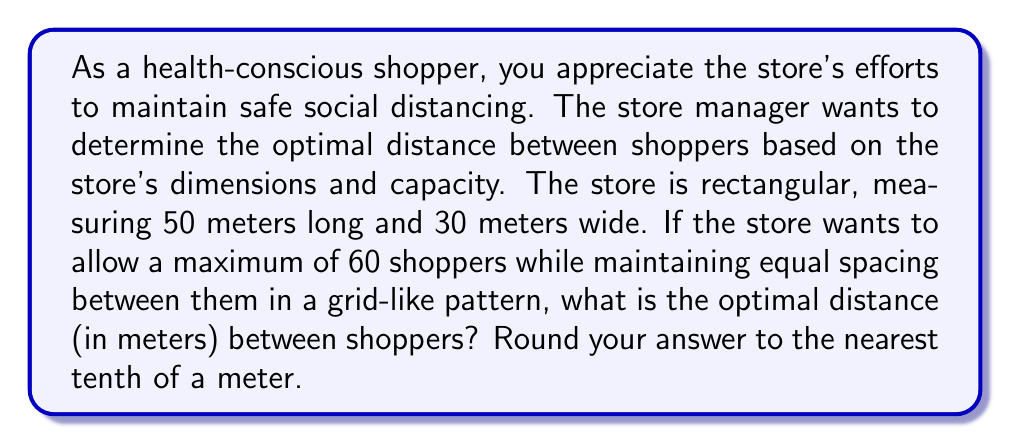Give your solution to this math problem. To solve this problem, we need to follow these steps:

1. Calculate the total area of the store:
   $$A = 50 \text{ m} \times 30 \text{ m} = 1500 \text{ m}^2$$

2. Determine the area per shopper:
   $$\text{Area per shopper} = \frac{\text{Total area}}{\text{Number of shoppers}} = \frac{1500 \text{ m}^2}{60} = 25 \text{ m}^2$$

3. Since we want a grid-like pattern with equal spacing, we can assume that each shopper occupies a square. The side length of this square will be the optimal distance between shoppers. Let's call this distance $d$.

4. The area of each square is $d^2$, which should equal the area per shopper:
   $$d^2 = 25 \text{ m}^2$$

5. Solve for $d$:
   $$d = \sqrt{25} = 5 \text{ m}$$

6. Round to the nearest tenth of a meter:
   $$d \approx 5.0 \text{ m}$$

This distance ensures that each shopper has an equal amount of space and that the store capacity is maintained while maximizing social distancing.
Answer: The optimal distance between shoppers for social distancing is 5.0 meters. 